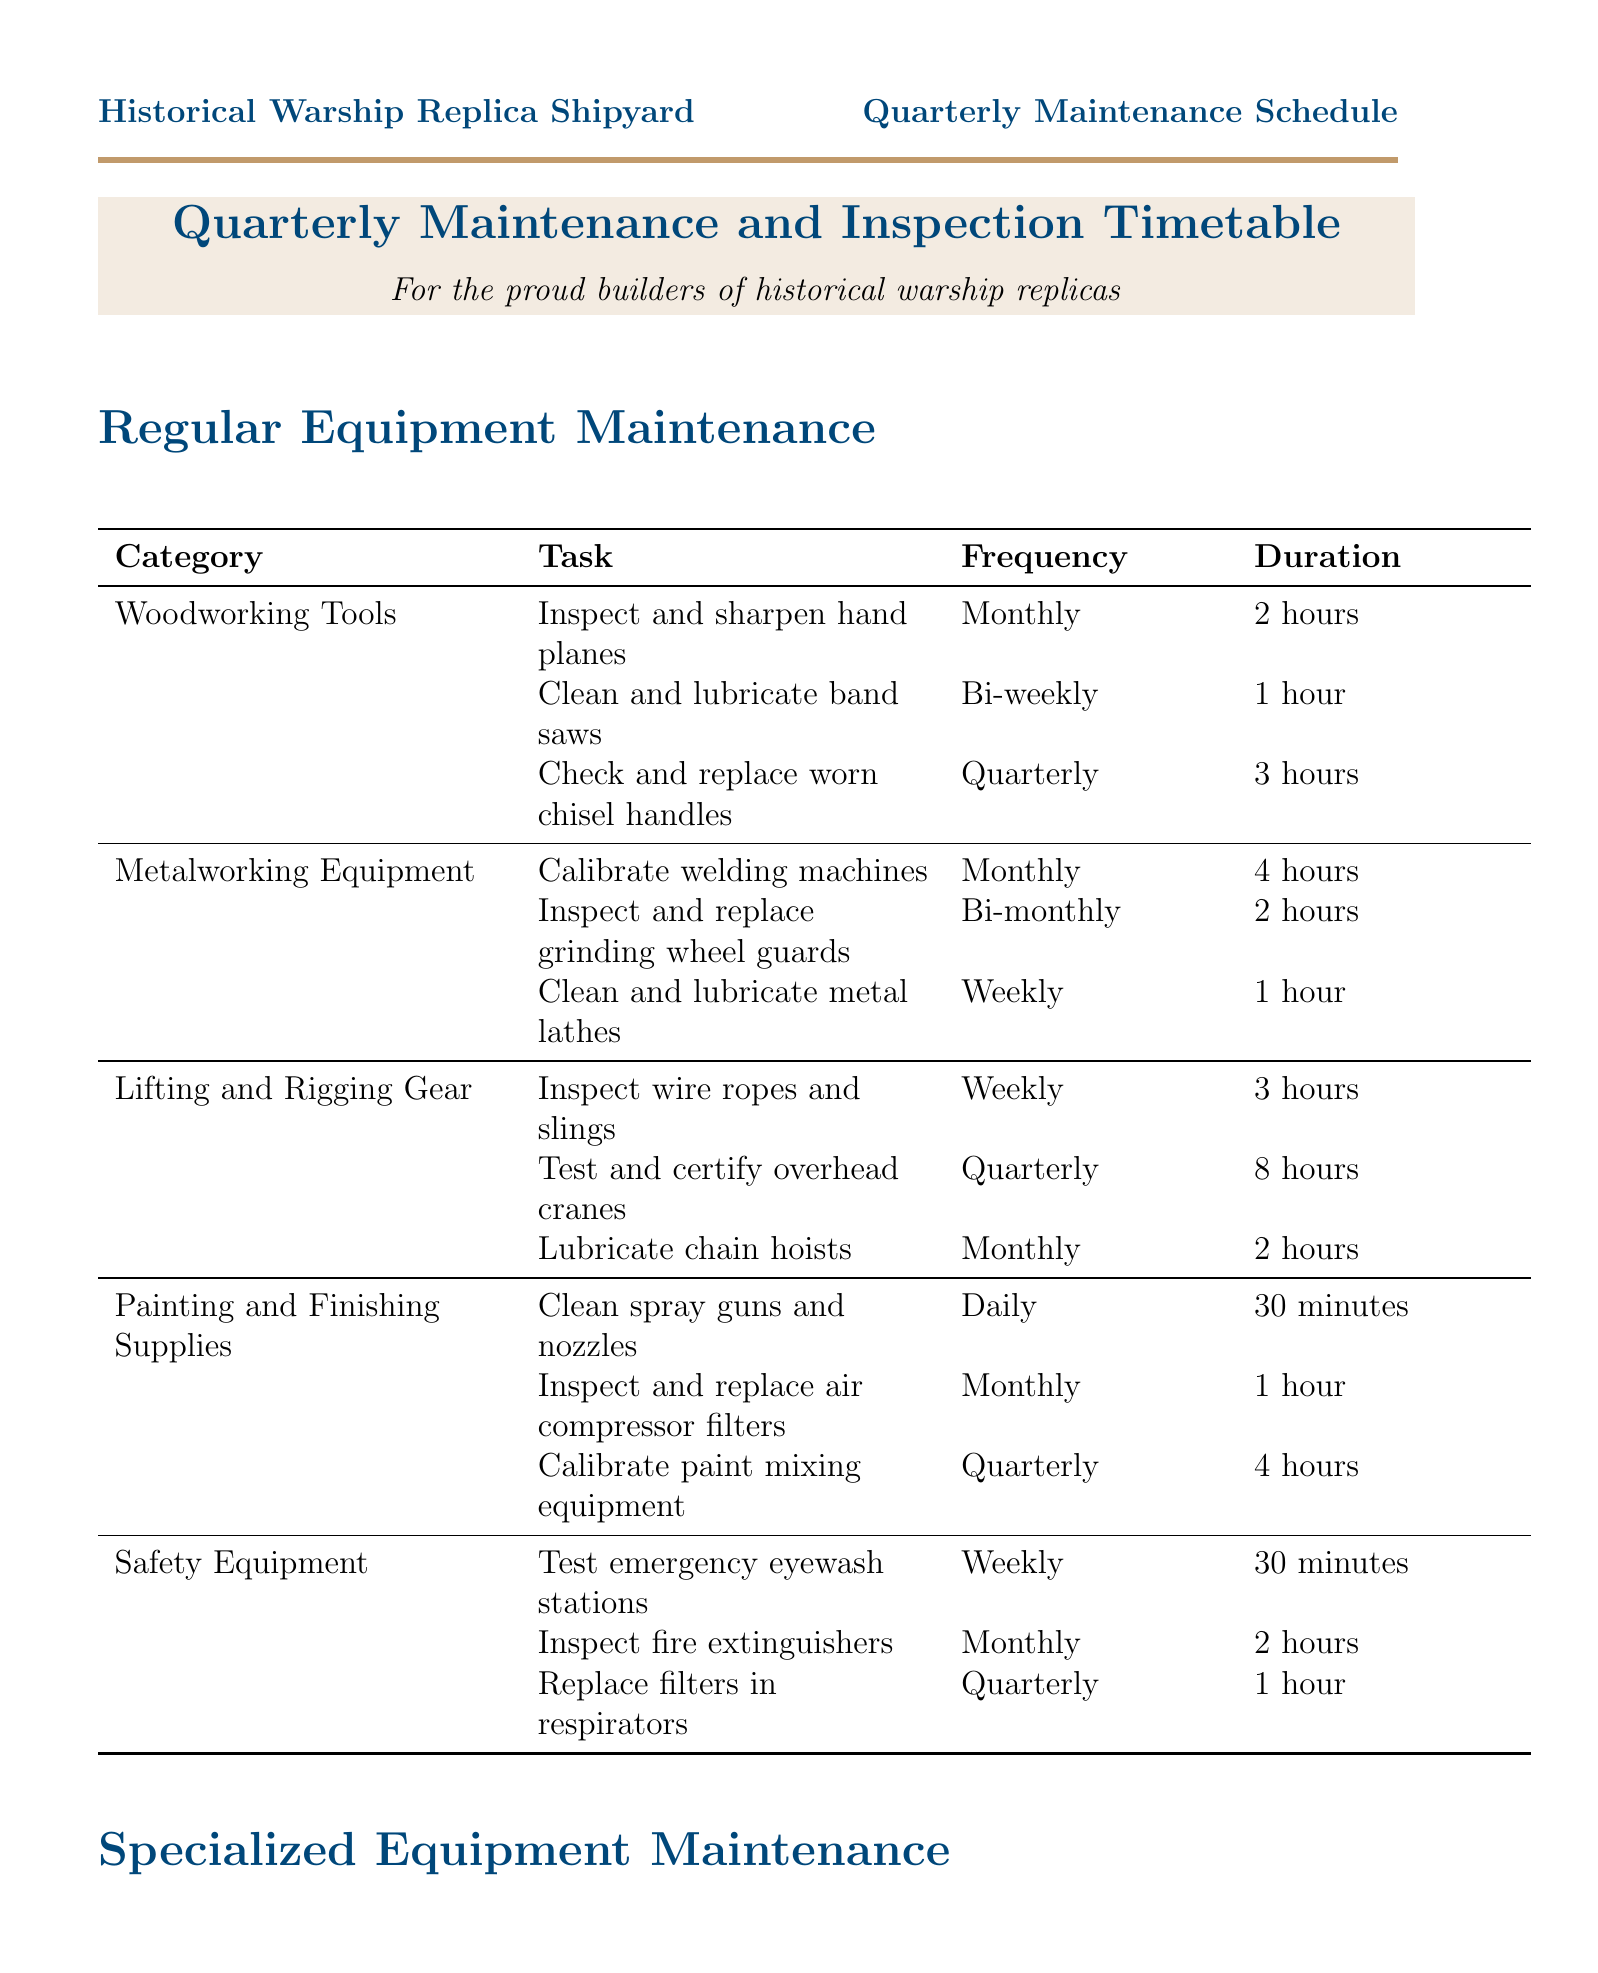what is the frequency for checking and replacing worn chisel handles? The schedule indicates the frequency for this task is quarterly.
Answer: Quarterly how long does it take to test and certify overhead cranes? The duration for this task is specified as eight hours in the document.
Answer: 8 hours what task is performed monthly for historical tool maintenance? The document mentions sharpening the blade and treating the wooden handle for the Adze as a monthly task.
Answer: Sharpen blade and treat wooden handle how many hours is the duration for inspecting and repairing the winch system? The duration for this task in the document is indicated as eight hours.
Answer: 8 hours what is the total number of categories listed for regular equipment maintenance? There are five categories mentioned in the document for regular equipment maintenance.
Answer: 5 which category has the task requiring the longest duration? The task of testing and certifying overhead cranes is found under Lifting and Rigging Gear and takes the longest.
Answer: Lifting and Rigging Gear which specialized equipment requires cleaning the steam generator? The document specifies that the steam bending machine requires this task to be performed weekly.
Answer: Steam bending machine what is the frequency for inspecting fire extinguishers? The frequency for this inspection task is monthly as per the document.
Answer: Monthly how long does it take to lubricate drive mechanisms on the replica cannon boring machine? The duration for this task is stated as one hour in the document.
Answer: 1 hour 